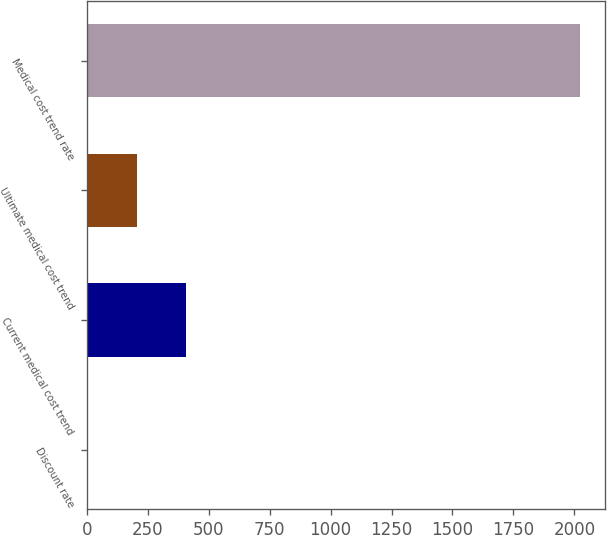<chart> <loc_0><loc_0><loc_500><loc_500><bar_chart><fcel>Discount rate<fcel>Current medical cost trend<fcel>Ultimate medical cost trend<fcel>Medical cost trend rate<nl><fcel>3.9<fcel>407.72<fcel>205.81<fcel>2023<nl></chart> 